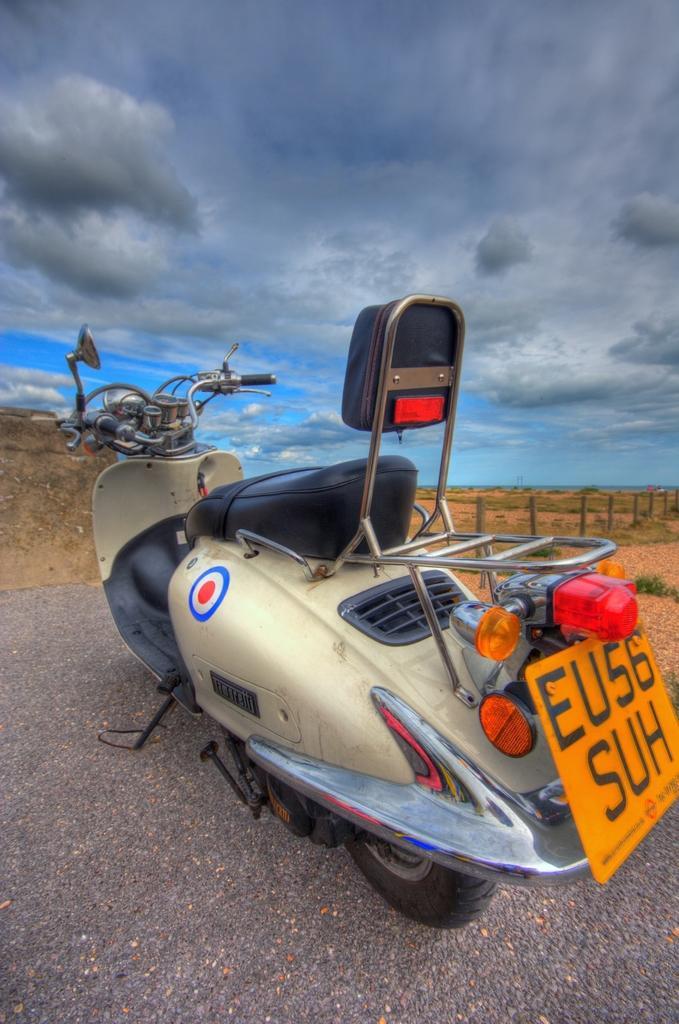Can you describe this image briefly? In the center of the image we can see a motorbike. At the bottom there is a road. In the background there is sky and we can see the fence. 